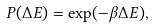Convert formula to latex. <formula><loc_0><loc_0><loc_500><loc_500>P ( \Delta E ) = \exp ( - \beta \Delta E ) ,</formula> 